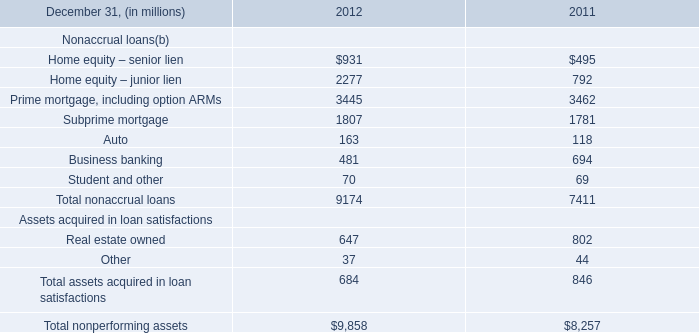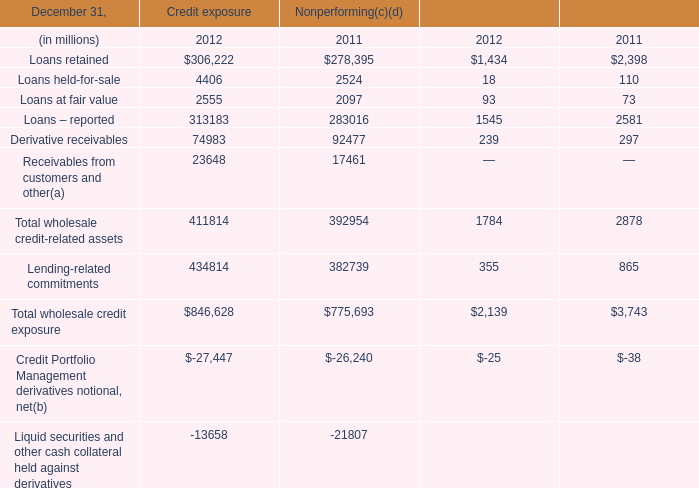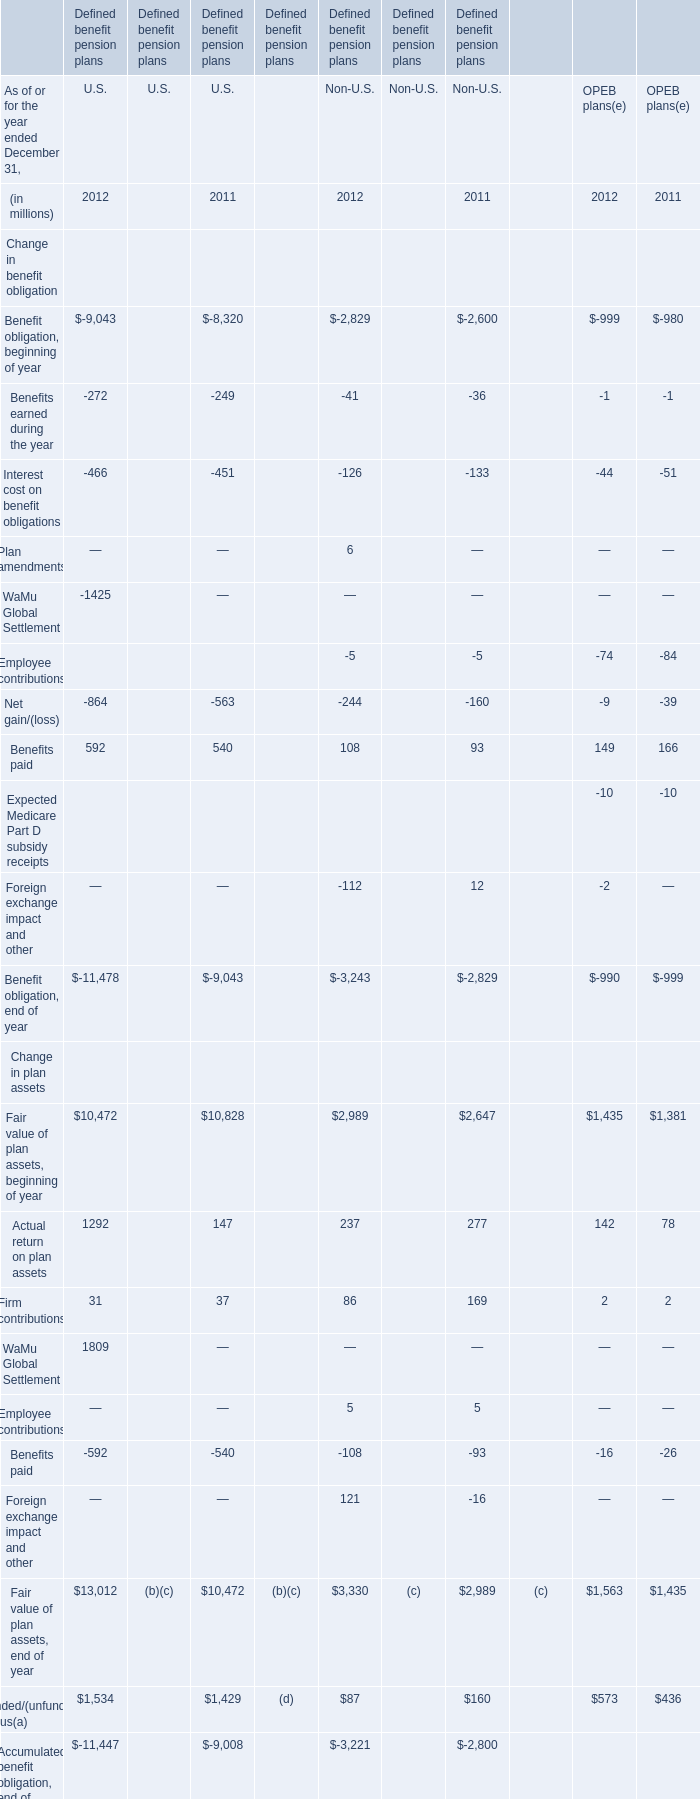What will Firm contributions for U.S reach in 2013 if it continues to grow at its current rate? (in million) 
Computations: ((1 + ((31 - 37) / 37)) * 31)
Answer: 25.97297. 